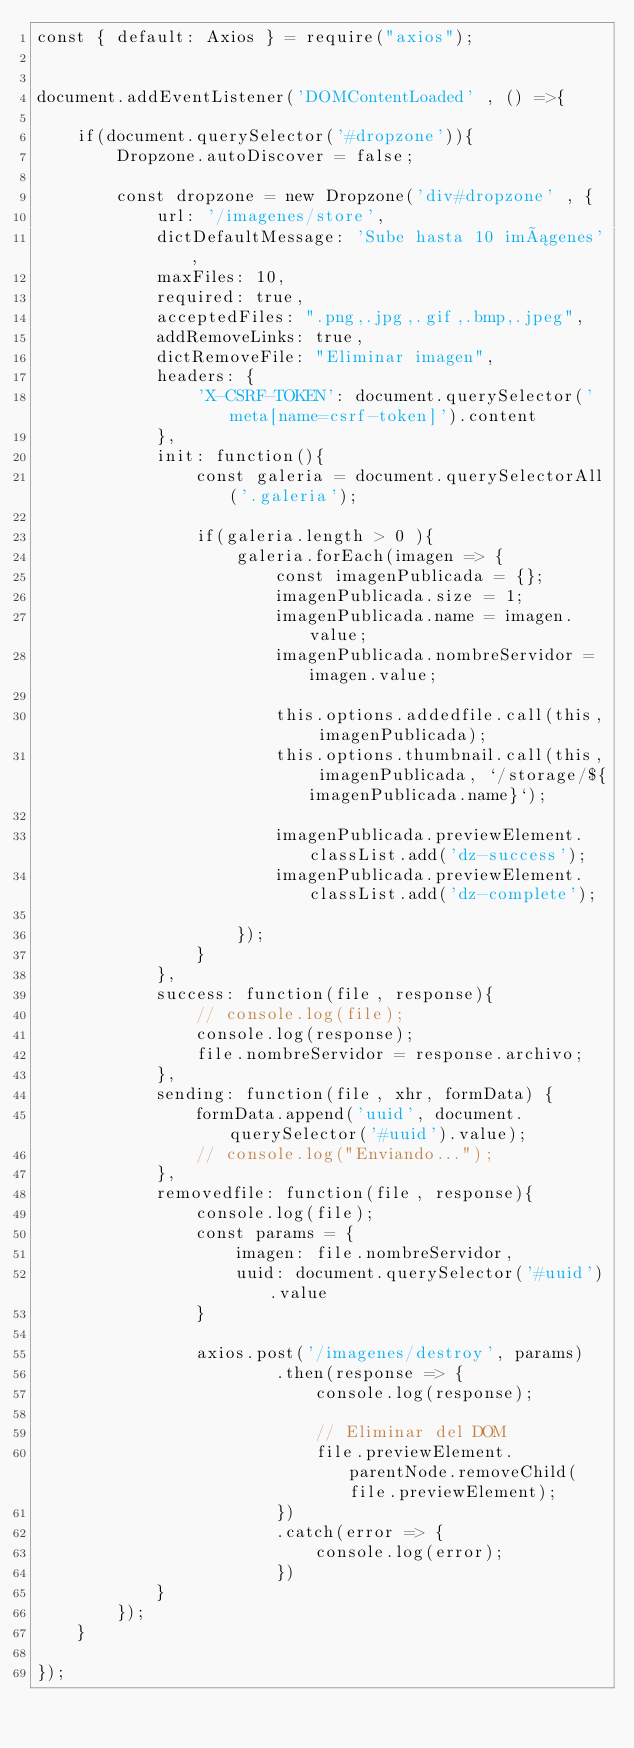<code> <loc_0><loc_0><loc_500><loc_500><_JavaScript_>const { default: Axios } = require("axios");


document.addEventListener('DOMContentLoaded' , () =>{

    if(document.querySelector('#dropzone')){
        Dropzone.autoDiscover = false;

        const dropzone = new Dropzone('div#dropzone' , {
            url: '/imagenes/store',
            dictDefaultMessage: 'Sube hasta 10 imágenes',
            maxFiles: 10,
            required: true,
            acceptedFiles: ".png,.jpg,.gif,.bmp,.jpeg",
            addRemoveLinks: true,
            dictRemoveFile: "Eliminar imagen",
            headers: {
                'X-CSRF-TOKEN': document.querySelector('meta[name=csrf-token]').content
            },
            init: function(){
                const galeria = document.querySelectorAll('.galeria');

                if(galeria.length > 0 ){
                    galeria.forEach(imagen => {
                        const imagenPublicada = {};
                        imagenPublicada.size = 1;
                        imagenPublicada.name = imagen.value;
                        imagenPublicada.nombreServidor = imagen.value;

                        this.options.addedfile.call(this, imagenPublicada);
                        this.options.thumbnail.call(this, imagenPublicada, `/storage/${imagenPublicada.name}`);

                        imagenPublicada.previewElement.classList.add('dz-success');
                        imagenPublicada.previewElement.classList.add('dz-complete');

                    });
                }
            },
            success: function(file, response){
                // console.log(file);
                console.log(response);
                file.nombreServidor = response.archivo;
            },
            sending: function(file, xhr, formData) {
                formData.append('uuid', document.querySelector('#uuid').value);
                // console.log("Enviando...");
            },
            removedfile: function(file, response){
                console.log(file);
                const params = {
                    imagen: file.nombreServidor,
                    uuid: document.querySelector('#uuid').value
                }

                axios.post('/imagenes/destroy', params)
                        .then(response => {
                            console.log(response);

                            // Eliminar del DOM
                            file.previewElement.parentNode.removeChild(file.previewElement);
                        })
                        .catch(error => {
                            console.log(error);
                        })
            }
        });
    }

});
</code> 